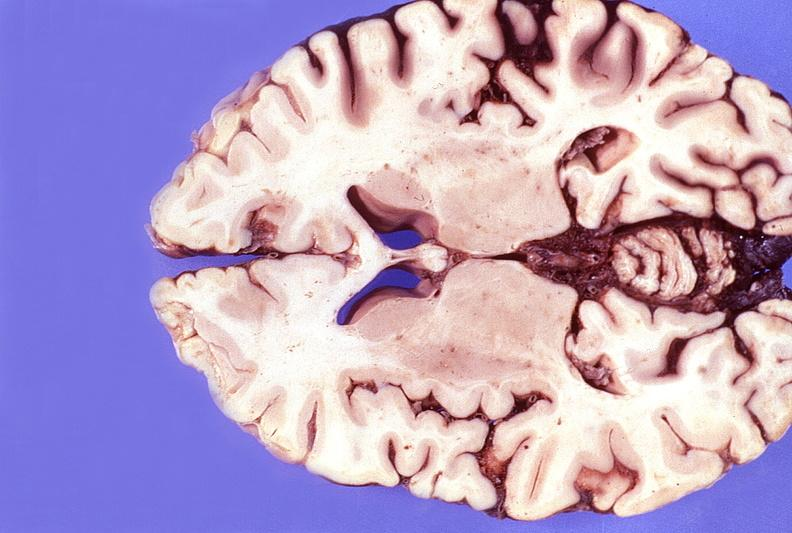does this image show normal brain?
Answer the question using a single word or phrase. Yes 